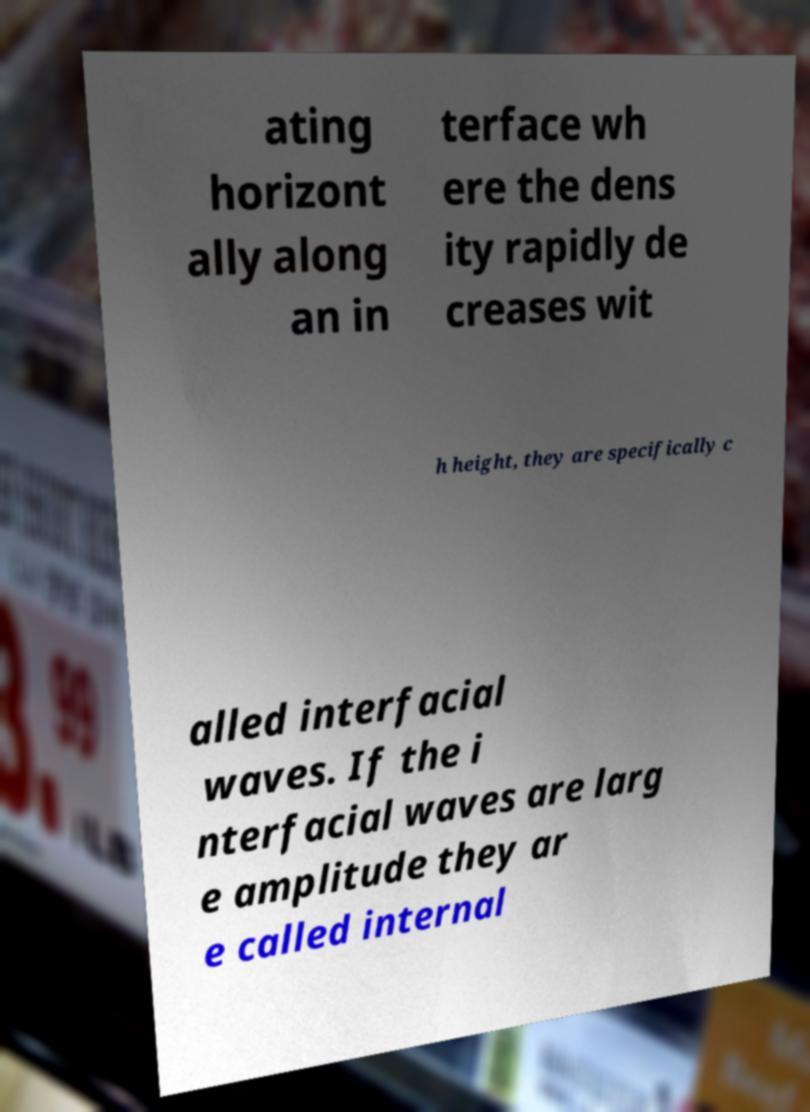Please identify and transcribe the text found in this image. ating horizont ally along an in terface wh ere the dens ity rapidly de creases wit h height, they are specifically c alled interfacial waves. If the i nterfacial waves are larg e amplitude they ar e called internal 